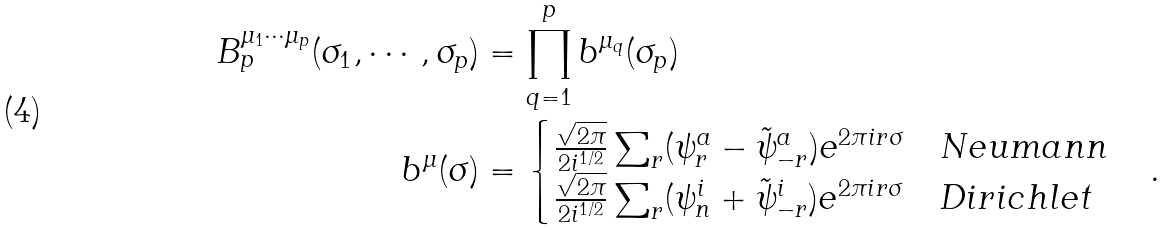Convert formula to latex. <formula><loc_0><loc_0><loc_500><loc_500>B _ { p } ^ { \mu _ { 1 } \cdots \mu _ { p } } ( \sigma _ { 1 } , \cdots , \sigma _ { p } ) & = \prod _ { q = 1 } ^ { p } b ^ { \mu _ { q } } ( \sigma _ { p } ) \\ b ^ { \mu } ( \sigma ) & = \begin{cases} \frac { \sqrt { 2 \pi } } { 2 i ^ { 1 / 2 } } \sum _ { r } ( \psi ^ { a } _ { r } - \tilde { \psi } ^ { a } _ { - r } ) e ^ { 2 \pi i r \sigma } \quad N e u m a n n \\ \frac { \sqrt { 2 \pi } } { 2 i ^ { 1 / 2 } } \sum _ { r } ( \psi ^ { i } _ { n } + \tilde { \psi } ^ { i } _ { - r } ) e ^ { 2 \pi i r \sigma } \quad D i r i c h l e t \end{cases} .</formula> 